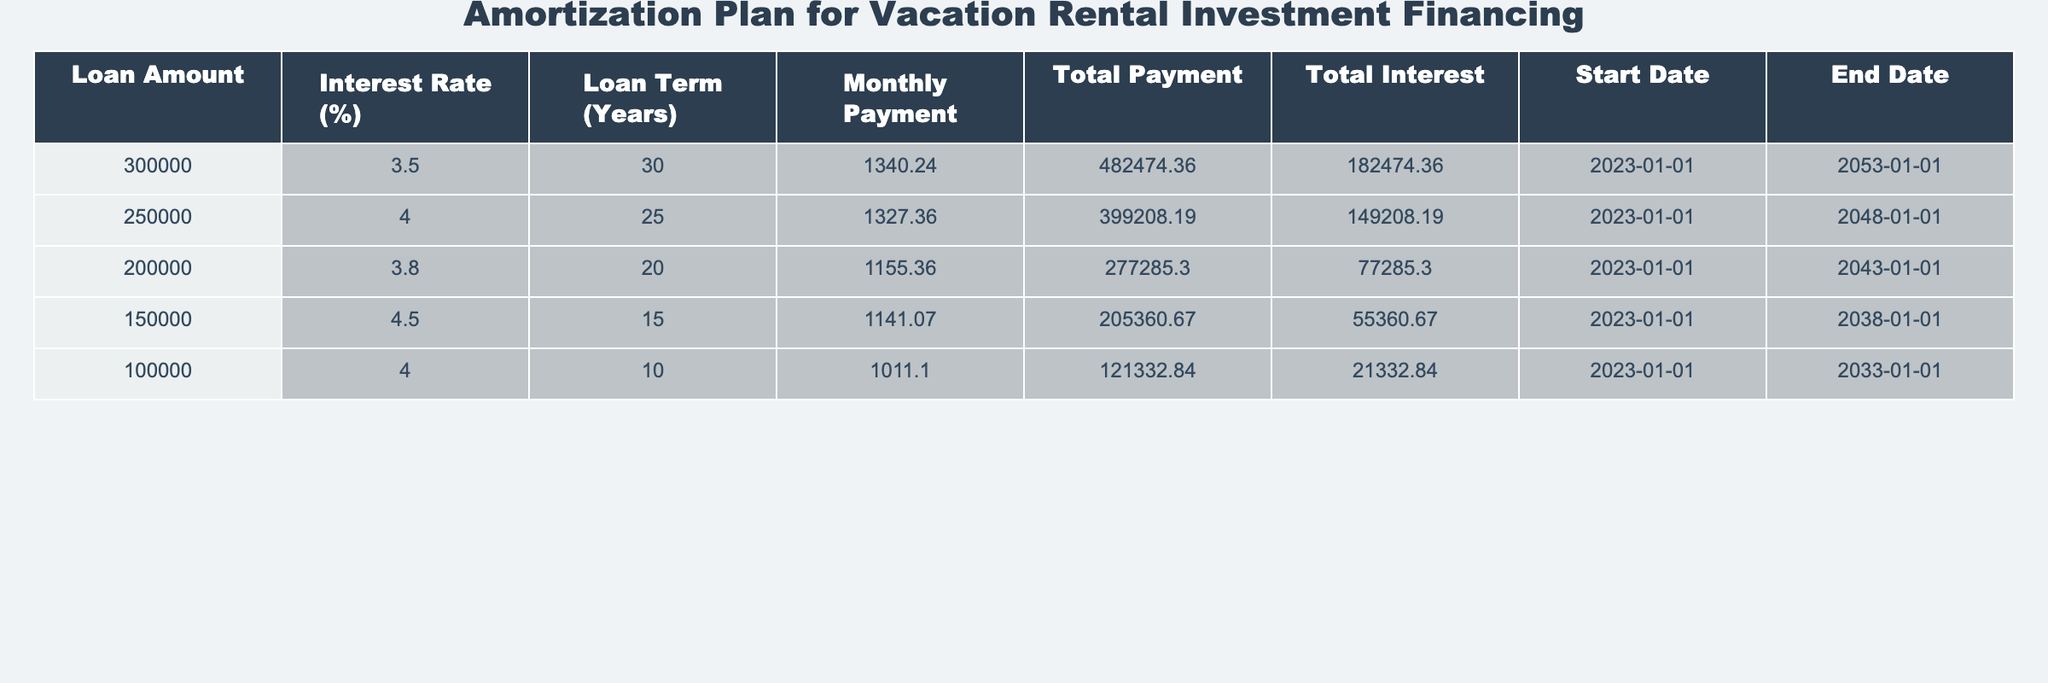What is the monthly payment for the loan of 300,000? The table lists the monthly payment corresponding to each loan amount. For the loan of 300,000, the monthly payment is explicitly stated as 1340.24.
Answer: 1340.24 What is the total interest paid over the term of the loan for 150,000? According to the table, the total interest for the loan amount of 150,000 is provided directly, which is 55360.67.
Answer: 55360.67 How long is the loan term for the loan amount of 200,000? The table indicates the loan term in years for the loan amount of 200,000, which is 20 years.
Answer: 20 years What is the difference in total payment between the loans of 300,000 and 250,000? From the table, the total payment for the loan of 300,000 is 482474.36 and for 250,000 it is 399208.19. The difference is calculated as 482474.36 - 399208.19, which equals 83266.17.
Answer: 83266.17 Is the total payment for the loan of 100,000 greater than the total interest for the loan of 150,000? The total payment for the loan of 100,000 is 121332.84, while the total interest for the loan of 150,000 is 55360.67. Since 121332.84 is greater than 55360.67, the answer is yes.
Answer: Yes Which loan has the lowest interest rate, and what is the rate? Reviewing the interest rates for each loan, the loan of 100,000 has the lowest rate at 4.0%.
Answer: 4.0% What is the average monthly payment across all the loans listed in the table? The monthly payments listed are 1340.24, 1327.36, 1155.36, 1141.07, and 1011.10. The sum of these payments is 6,975.13, and there are 5 loans, so the average is calculated by dividing 6,975.13 by 5, resulting in 1395.03.
Answer: 1395.03 If the loan of 150,000 had a term of 20 years instead of 15, how would that affect the total payment? The total payment for the loan of 150,000 for 15 years is 205360.67. To find an estimated payment for 20 years, one would typically expect the total to be higher due to accumulated interest over a longer term. However, specific calculation would be required for an exact answer, indicating that the answer cannot be determined without further data.
Answer: Cannot determine without calculation What is the end date for the loan of 100,000? The table specifies that the end date for the loan of 100,000 is 2033-01-01.
Answer: 2033-01-01 